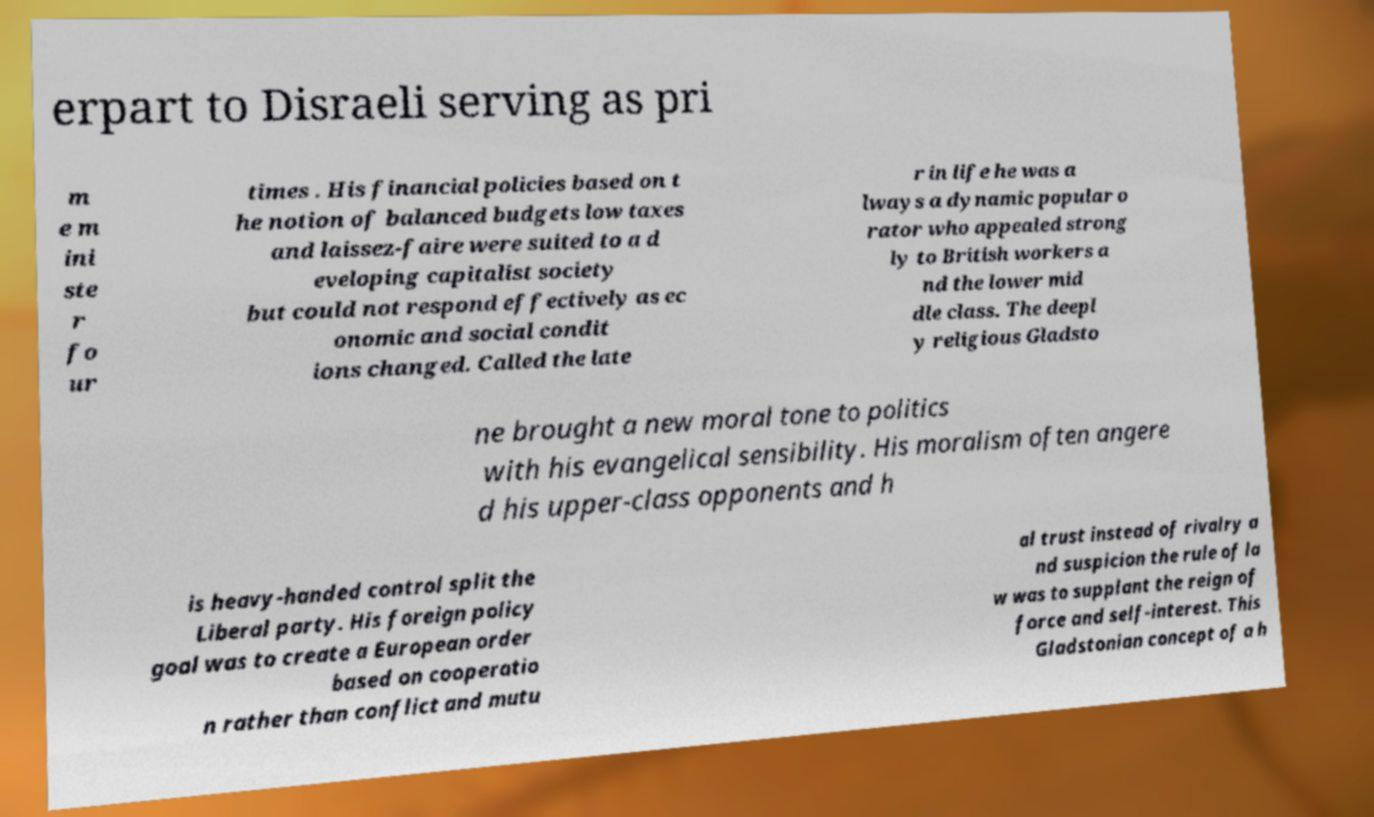I need the written content from this picture converted into text. Can you do that? erpart to Disraeli serving as pri m e m ini ste r fo ur times . His financial policies based on t he notion of balanced budgets low taxes and laissez-faire were suited to a d eveloping capitalist society but could not respond effectively as ec onomic and social condit ions changed. Called the late r in life he was a lways a dynamic popular o rator who appealed strong ly to British workers a nd the lower mid dle class. The deepl y religious Gladsto ne brought a new moral tone to politics with his evangelical sensibility. His moralism often angere d his upper-class opponents and h is heavy-handed control split the Liberal party. His foreign policy goal was to create a European order based on cooperatio n rather than conflict and mutu al trust instead of rivalry a nd suspicion the rule of la w was to supplant the reign of force and self-interest. This Gladstonian concept of a h 